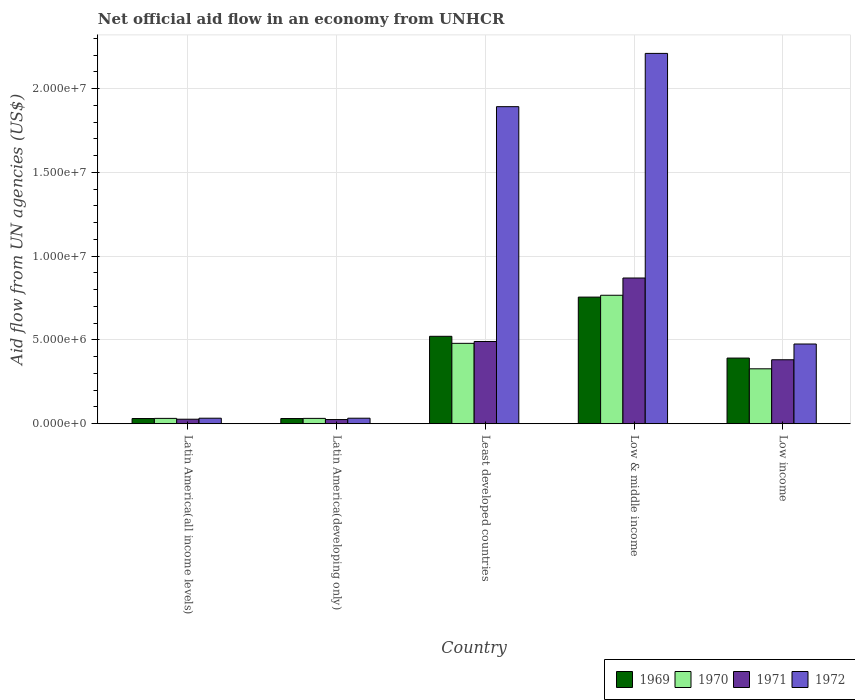How many groups of bars are there?
Ensure brevity in your answer.  5. Are the number of bars on each tick of the X-axis equal?
Your answer should be very brief. Yes. How many bars are there on the 2nd tick from the left?
Offer a very short reply. 4. How many bars are there on the 5th tick from the right?
Provide a short and direct response. 4. What is the label of the 3rd group of bars from the left?
Provide a short and direct response. Least developed countries. What is the net official aid flow in 1969 in Low & middle income?
Your answer should be very brief. 7.56e+06. Across all countries, what is the maximum net official aid flow in 1969?
Provide a short and direct response. 7.56e+06. In which country was the net official aid flow in 1969 minimum?
Give a very brief answer. Latin America(all income levels). What is the total net official aid flow in 1969 in the graph?
Keep it short and to the point. 1.73e+07. What is the difference between the net official aid flow in 1970 in Latin America(all income levels) and that in Low & middle income?
Your answer should be compact. -7.35e+06. What is the average net official aid flow in 1972 per country?
Your response must be concise. 9.29e+06. What is the difference between the net official aid flow of/in 1971 and net official aid flow of/in 1969 in Least developed countries?
Provide a succinct answer. -3.10e+05. In how many countries, is the net official aid flow in 1969 greater than 21000000 US$?
Ensure brevity in your answer.  0. What is the ratio of the net official aid flow in 1969 in Least developed countries to that in Low & middle income?
Your answer should be compact. 0.69. Is the net official aid flow in 1971 in Latin America(developing only) less than that in Low income?
Provide a short and direct response. Yes. Is the difference between the net official aid flow in 1971 in Least developed countries and Low income greater than the difference between the net official aid flow in 1969 in Least developed countries and Low income?
Offer a terse response. No. What is the difference between the highest and the second highest net official aid flow in 1971?
Ensure brevity in your answer.  4.88e+06. What is the difference between the highest and the lowest net official aid flow in 1971?
Give a very brief answer. 8.45e+06. In how many countries, is the net official aid flow in 1972 greater than the average net official aid flow in 1972 taken over all countries?
Make the answer very short. 2. Is it the case that in every country, the sum of the net official aid flow in 1972 and net official aid flow in 1970 is greater than the sum of net official aid flow in 1969 and net official aid flow in 1971?
Offer a very short reply. No. What does the 3rd bar from the left in Low & middle income represents?
Your response must be concise. 1971. What does the 1st bar from the right in Least developed countries represents?
Offer a very short reply. 1972. Is it the case that in every country, the sum of the net official aid flow in 1970 and net official aid flow in 1971 is greater than the net official aid flow in 1972?
Provide a succinct answer. No. How many countries are there in the graph?
Make the answer very short. 5. Does the graph contain any zero values?
Keep it short and to the point. No. Where does the legend appear in the graph?
Offer a very short reply. Bottom right. How many legend labels are there?
Ensure brevity in your answer.  4. How are the legend labels stacked?
Give a very brief answer. Horizontal. What is the title of the graph?
Your answer should be compact. Net official aid flow in an economy from UNHCR. Does "2001" appear as one of the legend labels in the graph?
Give a very brief answer. No. What is the label or title of the Y-axis?
Your response must be concise. Aid flow from UN agencies (US$). What is the Aid flow from UN agencies (US$) in 1971 in Latin America(all income levels)?
Make the answer very short. 2.70e+05. What is the Aid flow from UN agencies (US$) of 1970 in Latin America(developing only)?
Keep it short and to the point. 3.20e+05. What is the Aid flow from UN agencies (US$) in 1971 in Latin America(developing only)?
Your response must be concise. 2.50e+05. What is the Aid flow from UN agencies (US$) of 1969 in Least developed countries?
Give a very brief answer. 5.22e+06. What is the Aid flow from UN agencies (US$) of 1970 in Least developed countries?
Offer a terse response. 4.80e+06. What is the Aid flow from UN agencies (US$) in 1971 in Least developed countries?
Your answer should be very brief. 4.91e+06. What is the Aid flow from UN agencies (US$) of 1972 in Least developed countries?
Give a very brief answer. 1.89e+07. What is the Aid flow from UN agencies (US$) in 1969 in Low & middle income?
Give a very brief answer. 7.56e+06. What is the Aid flow from UN agencies (US$) in 1970 in Low & middle income?
Ensure brevity in your answer.  7.67e+06. What is the Aid flow from UN agencies (US$) of 1971 in Low & middle income?
Your answer should be very brief. 8.70e+06. What is the Aid flow from UN agencies (US$) in 1972 in Low & middle income?
Keep it short and to the point. 2.21e+07. What is the Aid flow from UN agencies (US$) of 1969 in Low income?
Your answer should be compact. 3.92e+06. What is the Aid flow from UN agencies (US$) in 1970 in Low income?
Your answer should be compact. 3.28e+06. What is the Aid flow from UN agencies (US$) of 1971 in Low income?
Offer a very short reply. 3.82e+06. What is the Aid flow from UN agencies (US$) in 1972 in Low income?
Keep it short and to the point. 4.76e+06. Across all countries, what is the maximum Aid flow from UN agencies (US$) of 1969?
Provide a short and direct response. 7.56e+06. Across all countries, what is the maximum Aid flow from UN agencies (US$) of 1970?
Your answer should be very brief. 7.67e+06. Across all countries, what is the maximum Aid flow from UN agencies (US$) of 1971?
Offer a terse response. 8.70e+06. Across all countries, what is the maximum Aid flow from UN agencies (US$) of 1972?
Offer a very short reply. 2.21e+07. Across all countries, what is the minimum Aid flow from UN agencies (US$) of 1969?
Offer a terse response. 3.10e+05. Across all countries, what is the minimum Aid flow from UN agencies (US$) of 1970?
Ensure brevity in your answer.  3.20e+05. Across all countries, what is the minimum Aid flow from UN agencies (US$) in 1972?
Give a very brief answer. 3.30e+05. What is the total Aid flow from UN agencies (US$) in 1969 in the graph?
Give a very brief answer. 1.73e+07. What is the total Aid flow from UN agencies (US$) in 1970 in the graph?
Ensure brevity in your answer.  1.64e+07. What is the total Aid flow from UN agencies (US$) in 1971 in the graph?
Provide a succinct answer. 1.80e+07. What is the total Aid flow from UN agencies (US$) in 1972 in the graph?
Give a very brief answer. 4.65e+07. What is the difference between the Aid flow from UN agencies (US$) in 1969 in Latin America(all income levels) and that in Latin America(developing only)?
Make the answer very short. 0. What is the difference between the Aid flow from UN agencies (US$) in 1970 in Latin America(all income levels) and that in Latin America(developing only)?
Provide a succinct answer. 0. What is the difference between the Aid flow from UN agencies (US$) in 1971 in Latin America(all income levels) and that in Latin America(developing only)?
Your answer should be compact. 2.00e+04. What is the difference between the Aid flow from UN agencies (US$) of 1969 in Latin America(all income levels) and that in Least developed countries?
Your response must be concise. -4.91e+06. What is the difference between the Aid flow from UN agencies (US$) of 1970 in Latin America(all income levels) and that in Least developed countries?
Your response must be concise. -4.48e+06. What is the difference between the Aid flow from UN agencies (US$) in 1971 in Latin America(all income levels) and that in Least developed countries?
Your response must be concise. -4.64e+06. What is the difference between the Aid flow from UN agencies (US$) in 1972 in Latin America(all income levels) and that in Least developed countries?
Ensure brevity in your answer.  -1.86e+07. What is the difference between the Aid flow from UN agencies (US$) in 1969 in Latin America(all income levels) and that in Low & middle income?
Make the answer very short. -7.25e+06. What is the difference between the Aid flow from UN agencies (US$) of 1970 in Latin America(all income levels) and that in Low & middle income?
Make the answer very short. -7.35e+06. What is the difference between the Aid flow from UN agencies (US$) of 1971 in Latin America(all income levels) and that in Low & middle income?
Provide a short and direct response. -8.43e+06. What is the difference between the Aid flow from UN agencies (US$) in 1972 in Latin America(all income levels) and that in Low & middle income?
Your answer should be compact. -2.18e+07. What is the difference between the Aid flow from UN agencies (US$) of 1969 in Latin America(all income levels) and that in Low income?
Provide a short and direct response. -3.61e+06. What is the difference between the Aid flow from UN agencies (US$) in 1970 in Latin America(all income levels) and that in Low income?
Offer a very short reply. -2.96e+06. What is the difference between the Aid flow from UN agencies (US$) in 1971 in Latin America(all income levels) and that in Low income?
Provide a short and direct response. -3.55e+06. What is the difference between the Aid flow from UN agencies (US$) in 1972 in Latin America(all income levels) and that in Low income?
Provide a succinct answer. -4.43e+06. What is the difference between the Aid flow from UN agencies (US$) of 1969 in Latin America(developing only) and that in Least developed countries?
Give a very brief answer. -4.91e+06. What is the difference between the Aid flow from UN agencies (US$) of 1970 in Latin America(developing only) and that in Least developed countries?
Your answer should be very brief. -4.48e+06. What is the difference between the Aid flow from UN agencies (US$) in 1971 in Latin America(developing only) and that in Least developed countries?
Provide a succinct answer. -4.66e+06. What is the difference between the Aid flow from UN agencies (US$) in 1972 in Latin America(developing only) and that in Least developed countries?
Give a very brief answer. -1.86e+07. What is the difference between the Aid flow from UN agencies (US$) in 1969 in Latin America(developing only) and that in Low & middle income?
Provide a short and direct response. -7.25e+06. What is the difference between the Aid flow from UN agencies (US$) in 1970 in Latin America(developing only) and that in Low & middle income?
Ensure brevity in your answer.  -7.35e+06. What is the difference between the Aid flow from UN agencies (US$) in 1971 in Latin America(developing only) and that in Low & middle income?
Keep it short and to the point. -8.45e+06. What is the difference between the Aid flow from UN agencies (US$) in 1972 in Latin America(developing only) and that in Low & middle income?
Give a very brief answer. -2.18e+07. What is the difference between the Aid flow from UN agencies (US$) in 1969 in Latin America(developing only) and that in Low income?
Give a very brief answer. -3.61e+06. What is the difference between the Aid flow from UN agencies (US$) in 1970 in Latin America(developing only) and that in Low income?
Your answer should be very brief. -2.96e+06. What is the difference between the Aid flow from UN agencies (US$) of 1971 in Latin America(developing only) and that in Low income?
Give a very brief answer. -3.57e+06. What is the difference between the Aid flow from UN agencies (US$) in 1972 in Latin America(developing only) and that in Low income?
Give a very brief answer. -4.43e+06. What is the difference between the Aid flow from UN agencies (US$) in 1969 in Least developed countries and that in Low & middle income?
Keep it short and to the point. -2.34e+06. What is the difference between the Aid flow from UN agencies (US$) of 1970 in Least developed countries and that in Low & middle income?
Give a very brief answer. -2.87e+06. What is the difference between the Aid flow from UN agencies (US$) of 1971 in Least developed countries and that in Low & middle income?
Offer a very short reply. -3.79e+06. What is the difference between the Aid flow from UN agencies (US$) in 1972 in Least developed countries and that in Low & middle income?
Ensure brevity in your answer.  -3.18e+06. What is the difference between the Aid flow from UN agencies (US$) in 1969 in Least developed countries and that in Low income?
Offer a terse response. 1.30e+06. What is the difference between the Aid flow from UN agencies (US$) in 1970 in Least developed countries and that in Low income?
Provide a succinct answer. 1.52e+06. What is the difference between the Aid flow from UN agencies (US$) of 1971 in Least developed countries and that in Low income?
Offer a terse response. 1.09e+06. What is the difference between the Aid flow from UN agencies (US$) in 1972 in Least developed countries and that in Low income?
Keep it short and to the point. 1.42e+07. What is the difference between the Aid flow from UN agencies (US$) in 1969 in Low & middle income and that in Low income?
Your answer should be compact. 3.64e+06. What is the difference between the Aid flow from UN agencies (US$) of 1970 in Low & middle income and that in Low income?
Give a very brief answer. 4.39e+06. What is the difference between the Aid flow from UN agencies (US$) of 1971 in Low & middle income and that in Low income?
Keep it short and to the point. 4.88e+06. What is the difference between the Aid flow from UN agencies (US$) in 1972 in Low & middle income and that in Low income?
Keep it short and to the point. 1.74e+07. What is the difference between the Aid flow from UN agencies (US$) of 1969 in Latin America(all income levels) and the Aid flow from UN agencies (US$) of 1970 in Latin America(developing only)?
Your response must be concise. -10000. What is the difference between the Aid flow from UN agencies (US$) in 1969 in Latin America(all income levels) and the Aid flow from UN agencies (US$) in 1970 in Least developed countries?
Keep it short and to the point. -4.49e+06. What is the difference between the Aid flow from UN agencies (US$) in 1969 in Latin America(all income levels) and the Aid flow from UN agencies (US$) in 1971 in Least developed countries?
Provide a short and direct response. -4.60e+06. What is the difference between the Aid flow from UN agencies (US$) of 1969 in Latin America(all income levels) and the Aid flow from UN agencies (US$) of 1972 in Least developed countries?
Offer a very short reply. -1.86e+07. What is the difference between the Aid flow from UN agencies (US$) in 1970 in Latin America(all income levels) and the Aid flow from UN agencies (US$) in 1971 in Least developed countries?
Offer a terse response. -4.59e+06. What is the difference between the Aid flow from UN agencies (US$) of 1970 in Latin America(all income levels) and the Aid flow from UN agencies (US$) of 1972 in Least developed countries?
Give a very brief answer. -1.86e+07. What is the difference between the Aid flow from UN agencies (US$) of 1971 in Latin America(all income levels) and the Aid flow from UN agencies (US$) of 1972 in Least developed countries?
Your answer should be very brief. -1.87e+07. What is the difference between the Aid flow from UN agencies (US$) in 1969 in Latin America(all income levels) and the Aid flow from UN agencies (US$) in 1970 in Low & middle income?
Your answer should be very brief. -7.36e+06. What is the difference between the Aid flow from UN agencies (US$) in 1969 in Latin America(all income levels) and the Aid flow from UN agencies (US$) in 1971 in Low & middle income?
Keep it short and to the point. -8.39e+06. What is the difference between the Aid flow from UN agencies (US$) in 1969 in Latin America(all income levels) and the Aid flow from UN agencies (US$) in 1972 in Low & middle income?
Give a very brief answer. -2.18e+07. What is the difference between the Aid flow from UN agencies (US$) of 1970 in Latin America(all income levels) and the Aid flow from UN agencies (US$) of 1971 in Low & middle income?
Ensure brevity in your answer.  -8.38e+06. What is the difference between the Aid flow from UN agencies (US$) in 1970 in Latin America(all income levels) and the Aid flow from UN agencies (US$) in 1972 in Low & middle income?
Provide a succinct answer. -2.18e+07. What is the difference between the Aid flow from UN agencies (US$) of 1971 in Latin America(all income levels) and the Aid flow from UN agencies (US$) of 1972 in Low & middle income?
Offer a very short reply. -2.18e+07. What is the difference between the Aid flow from UN agencies (US$) in 1969 in Latin America(all income levels) and the Aid flow from UN agencies (US$) in 1970 in Low income?
Your response must be concise. -2.97e+06. What is the difference between the Aid flow from UN agencies (US$) of 1969 in Latin America(all income levels) and the Aid flow from UN agencies (US$) of 1971 in Low income?
Ensure brevity in your answer.  -3.51e+06. What is the difference between the Aid flow from UN agencies (US$) of 1969 in Latin America(all income levels) and the Aid flow from UN agencies (US$) of 1972 in Low income?
Keep it short and to the point. -4.45e+06. What is the difference between the Aid flow from UN agencies (US$) in 1970 in Latin America(all income levels) and the Aid flow from UN agencies (US$) in 1971 in Low income?
Keep it short and to the point. -3.50e+06. What is the difference between the Aid flow from UN agencies (US$) of 1970 in Latin America(all income levels) and the Aid flow from UN agencies (US$) of 1972 in Low income?
Provide a short and direct response. -4.44e+06. What is the difference between the Aid flow from UN agencies (US$) in 1971 in Latin America(all income levels) and the Aid flow from UN agencies (US$) in 1972 in Low income?
Make the answer very short. -4.49e+06. What is the difference between the Aid flow from UN agencies (US$) of 1969 in Latin America(developing only) and the Aid flow from UN agencies (US$) of 1970 in Least developed countries?
Provide a short and direct response. -4.49e+06. What is the difference between the Aid flow from UN agencies (US$) in 1969 in Latin America(developing only) and the Aid flow from UN agencies (US$) in 1971 in Least developed countries?
Make the answer very short. -4.60e+06. What is the difference between the Aid flow from UN agencies (US$) of 1969 in Latin America(developing only) and the Aid flow from UN agencies (US$) of 1972 in Least developed countries?
Your response must be concise. -1.86e+07. What is the difference between the Aid flow from UN agencies (US$) of 1970 in Latin America(developing only) and the Aid flow from UN agencies (US$) of 1971 in Least developed countries?
Offer a very short reply. -4.59e+06. What is the difference between the Aid flow from UN agencies (US$) in 1970 in Latin America(developing only) and the Aid flow from UN agencies (US$) in 1972 in Least developed countries?
Give a very brief answer. -1.86e+07. What is the difference between the Aid flow from UN agencies (US$) in 1971 in Latin America(developing only) and the Aid flow from UN agencies (US$) in 1972 in Least developed countries?
Your answer should be compact. -1.87e+07. What is the difference between the Aid flow from UN agencies (US$) in 1969 in Latin America(developing only) and the Aid flow from UN agencies (US$) in 1970 in Low & middle income?
Provide a short and direct response. -7.36e+06. What is the difference between the Aid flow from UN agencies (US$) in 1969 in Latin America(developing only) and the Aid flow from UN agencies (US$) in 1971 in Low & middle income?
Provide a succinct answer. -8.39e+06. What is the difference between the Aid flow from UN agencies (US$) in 1969 in Latin America(developing only) and the Aid flow from UN agencies (US$) in 1972 in Low & middle income?
Ensure brevity in your answer.  -2.18e+07. What is the difference between the Aid flow from UN agencies (US$) in 1970 in Latin America(developing only) and the Aid flow from UN agencies (US$) in 1971 in Low & middle income?
Make the answer very short. -8.38e+06. What is the difference between the Aid flow from UN agencies (US$) in 1970 in Latin America(developing only) and the Aid flow from UN agencies (US$) in 1972 in Low & middle income?
Your answer should be very brief. -2.18e+07. What is the difference between the Aid flow from UN agencies (US$) in 1971 in Latin America(developing only) and the Aid flow from UN agencies (US$) in 1972 in Low & middle income?
Give a very brief answer. -2.19e+07. What is the difference between the Aid flow from UN agencies (US$) in 1969 in Latin America(developing only) and the Aid flow from UN agencies (US$) in 1970 in Low income?
Keep it short and to the point. -2.97e+06. What is the difference between the Aid flow from UN agencies (US$) of 1969 in Latin America(developing only) and the Aid flow from UN agencies (US$) of 1971 in Low income?
Offer a very short reply. -3.51e+06. What is the difference between the Aid flow from UN agencies (US$) in 1969 in Latin America(developing only) and the Aid flow from UN agencies (US$) in 1972 in Low income?
Give a very brief answer. -4.45e+06. What is the difference between the Aid flow from UN agencies (US$) of 1970 in Latin America(developing only) and the Aid flow from UN agencies (US$) of 1971 in Low income?
Provide a succinct answer. -3.50e+06. What is the difference between the Aid flow from UN agencies (US$) in 1970 in Latin America(developing only) and the Aid flow from UN agencies (US$) in 1972 in Low income?
Your answer should be compact. -4.44e+06. What is the difference between the Aid flow from UN agencies (US$) of 1971 in Latin America(developing only) and the Aid flow from UN agencies (US$) of 1972 in Low income?
Give a very brief answer. -4.51e+06. What is the difference between the Aid flow from UN agencies (US$) of 1969 in Least developed countries and the Aid flow from UN agencies (US$) of 1970 in Low & middle income?
Make the answer very short. -2.45e+06. What is the difference between the Aid flow from UN agencies (US$) of 1969 in Least developed countries and the Aid flow from UN agencies (US$) of 1971 in Low & middle income?
Provide a short and direct response. -3.48e+06. What is the difference between the Aid flow from UN agencies (US$) in 1969 in Least developed countries and the Aid flow from UN agencies (US$) in 1972 in Low & middle income?
Provide a short and direct response. -1.69e+07. What is the difference between the Aid flow from UN agencies (US$) of 1970 in Least developed countries and the Aid flow from UN agencies (US$) of 1971 in Low & middle income?
Provide a short and direct response. -3.90e+06. What is the difference between the Aid flow from UN agencies (US$) in 1970 in Least developed countries and the Aid flow from UN agencies (US$) in 1972 in Low & middle income?
Your response must be concise. -1.73e+07. What is the difference between the Aid flow from UN agencies (US$) of 1971 in Least developed countries and the Aid flow from UN agencies (US$) of 1972 in Low & middle income?
Offer a very short reply. -1.72e+07. What is the difference between the Aid flow from UN agencies (US$) of 1969 in Least developed countries and the Aid flow from UN agencies (US$) of 1970 in Low income?
Your response must be concise. 1.94e+06. What is the difference between the Aid flow from UN agencies (US$) of 1969 in Least developed countries and the Aid flow from UN agencies (US$) of 1971 in Low income?
Make the answer very short. 1.40e+06. What is the difference between the Aid flow from UN agencies (US$) in 1969 in Least developed countries and the Aid flow from UN agencies (US$) in 1972 in Low income?
Provide a short and direct response. 4.60e+05. What is the difference between the Aid flow from UN agencies (US$) in 1970 in Least developed countries and the Aid flow from UN agencies (US$) in 1971 in Low income?
Your answer should be very brief. 9.80e+05. What is the difference between the Aid flow from UN agencies (US$) in 1969 in Low & middle income and the Aid flow from UN agencies (US$) in 1970 in Low income?
Your response must be concise. 4.28e+06. What is the difference between the Aid flow from UN agencies (US$) of 1969 in Low & middle income and the Aid flow from UN agencies (US$) of 1971 in Low income?
Your response must be concise. 3.74e+06. What is the difference between the Aid flow from UN agencies (US$) in 1969 in Low & middle income and the Aid flow from UN agencies (US$) in 1972 in Low income?
Provide a short and direct response. 2.80e+06. What is the difference between the Aid flow from UN agencies (US$) of 1970 in Low & middle income and the Aid flow from UN agencies (US$) of 1971 in Low income?
Provide a succinct answer. 3.85e+06. What is the difference between the Aid flow from UN agencies (US$) in 1970 in Low & middle income and the Aid flow from UN agencies (US$) in 1972 in Low income?
Make the answer very short. 2.91e+06. What is the difference between the Aid flow from UN agencies (US$) in 1971 in Low & middle income and the Aid flow from UN agencies (US$) in 1972 in Low income?
Keep it short and to the point. 3.94e+06. What is the average Aid flow from UN agencies (US$) in 1969 per country?
Keep it short and to the point. 3.46e+06. What is the average Aid flow from UN agencies (US$) in 1970 per country?
Your answer should be compact. 3.28e+06. What is the average Aid flow from UN agencies (US$) of 1971 per country?
Your answer should be very brief. 3.59e+06. What is the average Aid flow from UN agencies (US$) of 1972 per country?
Give a very brief answer. 9.29e+06. What is the difference between the Aid flow from UN agencies (US$) of 1969 and Aid flow from UN agencies (US$) of 1970 in Latin America(all income levels)?
Your answer should be very brief. -10000. What is the difference between the Aid flow from UN agencies (US$) in 1969 and Aid flow from UN agencies (US$) in 1971 in Latin America(all income levels)?
Keep it short and to the point. 4.00e+04. What is the difference between the Aid flow from UN agencies (US$) of 1970 and Aid flow from UN agencies (US$) of 1971 in Latin America(all income levels)?
Offer a terse response. 5.00e+04. What is the difference between the Aid flow from UN agencies (US$) in 1971 and Aid flow from UN agencies (US$) in 1972 in Latin America(all income levels)?
Your answer should be very brief. -6.00e+04. What is the difference between the Aid flow from UN agencies (US$) of 1969 and Aid flow from UN agencies (US$) of 1971 in Latin America(developing only)?
Make the answer very short. 6.00e+04. What is the difference between the Aid flow from UN agencies (US$) of 1970 and Aid flow from UN agencies (US$) of 1971 in Latin America(developing only)?
Offer a very short reply. 7.00e+04. What is the difference between the Aid flow from UN agencies (US$) of 1970 and Aid flow from UN agencies (US$) of 1972 in Latin America(developing only)?
Your response must be concise. -10000. What is the difference between the Aid flow from UN agencies (US$) in 1971 and Aid flow from UN agencies (US$) in 1972 in Latin America(developing only)?
Make the answer very short. -8.00e+04. What is the difference between the Aid flow from UN agencies (US$) in 1969 and Aid flow from UN agencies (US$) in 1972 in Least developed countries?
Offer a terse response. -1.37e+07. What is the difference between the Aid flow from UN agencies (US$) in 1970 and Aid flow from UN agencies (US$) in 1972 in Least developed countries?
Offer a very short reply. -1.41e+07. What is the difference between the Aid flow from UN agencies (US$) in 1971 and Aid flow from UN agencies (US$) in 1972 in Least developed countries?
Provide a succinct answer. -1.40e+07. What is the difference between the Aid flow from UN agencies (US$) in 1969 and Aid flow from UN agencies (US$) in 1970 in Low & middle income?
Offer a terse response. -1.10e+05. What is the difference between the Aid flow from UN agencies (US$) in 1969 and Aid flow from UN agencies (US$) in 1971 in Low & middle income?
Your response must be concise. -1.14e+06. What is the difference between the Aid flow from UN agencies (US$) of 1969 and Aid flow from UN agencies (US$) of 1972 in Low & middle income?
Provide a succinct answer. -1.46e+07. What is the difference between the Aid flow from UN agencies (US$) in 1970 and Aid flow from UN agencies (US$) in 1971 in Low & middle income?
Provide a succinct answer. -1.03e+06. What is the difference between the Aid flow from UN agencies (US$) in 1970 and Aid flow from UN agencies (US$) in 1972 in Low & middle income?
Your answer should be compact. -1.44e+07. What is the difference between the Aid flow from UN agencies (US$) in 1971 and Aid flow from UN agencies (US$) in 1972 in Low & middle income?
Offer a terse response. -1.34e+07. What is the difference between the Aid flow from UN agencies (US$) of 1969 and Aid flow from UN agencies (US$) of 1970 in Low income?
Provide a short and direct response. 6.40e+05. What is the difference between the Aid flow from UN agencies (US$) in 1969 and Aid flow from UN agencies (US$) in 1972 in Low income?
Provide a succinct answer. -8.40e+05. What is the difference between the Aid flow from UN agencies (US$) of 1970 and Aid flow from UN agencies (US$) of 1971 in Low income?
Your answer should be very brief. -5.40e+05. What is the difference between the Aid flow from UN agencies (US$) in 1970 and Aid flow from UN agencies (US$) in 1972 in Low income?
Your answer should be compact. -1.48e+06. What is the difference between the Aid flow from UN agencies (US$) of 1971 and Aid flow from UN agencies (US$) of 1972 in Low income?
Make the answer very short. -9.40e+05. What is the ratio of the Aid flow from UN agencies (US$) in 1969 in Latin America(all income levels) to that in Latin America(developing only)?
Provide a succinct answer. 1. What is the ratio of the Aid flow from UN agencies (US$) of 1971 in Latin America(all income levels) to that in Latin America(developing only)?
Offer a terse response. 1.08. What is the ratio of the Aid flow from UN agencies (US$) in 1972 in Latin America(all income levels) to that in Latin America(developing only)?
Provide a short and direct response. 1. What is the ratio of the Aid flow from UN agencies (US$) in 1969 in Latin America(all income levels) to that in Least developed countries?
Ensure brevity in your answer.  0.06. What is the ratio of the Aid flow from UN agencies (US$) in 1970 in Latin America(all income levels) to that in Least developed countries?
Keep it short and to the point. 0.07. What is the ratio of the Aid flow from UN agencies (US$) in 1971 in Latin America(all income levels) to that in Least developed countries?
Your answer should be compact. 0.06. What is the ratio of the Aid flow from UN agencies (US$) of 1972 in Latin America(all income levels) to that in Least developed countries?
Your answer should be compact. 0.02. What is the ratio of the Aid flow from UN agencies (US$) in 1969 in Latin America(all income levels) to that in Low & middle income?
Keep it short and to the point. 0.04. What is the ratio of the Aid flow from UN agencies (US$) of 1970 in Latin America(all income levels) to that in Low & middle income?
Keep it short and to the point. 0.04. What is the ratio of the Aid flow from UN agencies (US$) of 1971 in Latin America(all income levels) to that in Low & middle income?
Provide a succinct answer. 0.03. What is the ratio of the Aid flow from UN agencies (US$) in 1972 in Latin America(all income levels) to that in Low & middle income?
Your answer should be compact. 0.01. What is the ratio of the Aid flow from UN agencies (US$) of 1969 in Latin America(all income levels) to that in Low income?
Your answer should be very brief. 0.08. What is the ratio of the Aid flow from UN agencies (US$) of 1970 in Latin America(all income levels) to that in Low income?
Provide a succinct answer. 0.1. What is the ratio of the Aid flow from UN agencies (US$) of 1971 in Latin America(all income levels) to that in Low income?
Your response must be concise. 0.07. What is the ratio of the Aid flow from UN agencies (US$) of 1972 in Latin America(all income levels) to that in Low income?
Offer a terse response. 0.07. What is the ratio of the Aid flow from UN agencies (US$) of 1969 in Latin America(developing only) to that in Least developed countries?
Your response must be concise. 0.06. What is the ratio of the Aid flow from UN agencies (US$) in 1970 in Latin America(developing only) to that in Least developed countries?
Your response must be concise. 0.07. What is the ratio of the Aid flow from UN agencies (US$) in 1971 in Latin America(developing only) to that in Least developed countries?
Keep it short and to the point. 0.05. What is the ratio of the Aid flow from UN agencies (US$) in 1972 in Latin America(developing only) to that in Least developed countries?
Keep it short and to the point. 0.02. What is the ratio of the Aid flow from UN agencies (US$) of 1969 in Latin America(developing only) to that in Low & middle income?
Your answer should be compact. 0.04. What is the ratio of the Aid flow from UN agencies (US$) of 1970 in Latin America(developing only) to that in Low & middle income?
Offer a terse response. 0.04. What is the ratio of the Aid flow from UN agencies (US$) of 1971 in Latin America(developing only) to that in Low & middle income?
Make the answer very short. 0.03. What is the ratio of the Aid flow from UN agencies (US$) in 1972 in Latin America(developing only) to that in Low & middle income?
Make the answer very short. 0.01. What is the ratio of the Aid flow from UN agencies (US$) of 1969 in Latin America(developing only) to that in Low income?
Keep it short and to the point. 0.08. What is the ratio of the Aid flow from UN agencies (US$) of 1970 in Latin America(developing only) to that in Low income?
Give a very brief answer. 0.1. What is the ratio of the Aid flow from UN agencies (US$) of 1971 in Latin America(developing only) to that in Low income?
Your answer should be very brief. 0.07. What is the ratio of the Aid flow from UN agencies (US$) of 1972 in Latin America(developing only) to that in Low income?
Your answer should be compact. 0.07. What is the ratio of the Aid flow from UN agencies (US$) in 1969 in Least developed countries to that in Low & middle income?
Provide a short and direct response. 0.69. What is the ratio of the Aid flow from UN agencies (US$) in 1970 in Least developed countries to that in Low & middle income?
Provide a succinct answer. 0.63. What is the ratio of the Aid flow from UN agencies (US$) in 1971 in Least developed countries to that in Low & middle income?
Your answer should be very brief. 0.56. What is the ratio of the Aid flow from UN agencies (US$) of 1972 in Least developed countries to that in Low & middle income?
Offer a terse response. 0.86. What is the ratio of the Aid flow from UN agencies (US$) in 1969 in Least developed countries to that in Low income?
Keep it short and to the point. 1.33. What is the ratio of the Aid flow from UN agencies (US$) of 1970 in Least developed countries to that in Low income?
Ensure brevity in your answer.  1.46. What is the ratio of the Aid flow from UN agencies (US$) of 1971 in Least developed countries to that in Low income?
Make the answer very short. 1.29. What is the ratio of the Aid flow from UN agencies (US$) of 1972 in Least developed countries to that in Low income?
Offer a terse response. 3.98. What is the ratio of the Aid flow from UN agencies (US$) in 1969 in Low & middle income to that in Low income?
Offer a terse response. 1.93. What is the ratio of the Aid flow from UN agencies (US$) of 1970 in Low & middle income to that in Low income?
Provide a short and direct response. 2.34. What is the ratio of the Aid flow from UN agencies (US$) in 1971 in Low & middle income to that in Low income?
Keep it short and to the point. 2.28. What is the ratio of the Aid flow from UN agencies (US$) in 1972 in Low & middle income to that in Low income?
Your answer should be compact. 4.64. What is the difference between the highest and the second highest Aid flow from UN agencies (US$) in 1969?
Provide a succinct answer. 2.34e+06. What is the difference between the highest and the second highest Aid flow from UN agencies (US$) of 1970?
Provide a short and direct response. 2.87e+06. What is the difference between the highest and the second highest Aid flow from UN agencies (US$) of 1971?
Offer a very short reply. 3.79e+06. What is the difference between the highest and the second highest Aid flow from UN agencies (US$) in 1972?
Ensure brevity in your answer.  3.18e+06. What is the difference between the highest and the lowest Aid flow from UN agencies (US$) in 1969?
Your response must be concise. 7.25e+06. What is the difference between the highest and the lowest Aid flow from UN agencies (US$) in 1970?
Your answer should be compact. 7.35e+06. What is the difference between the highest and the lowest Aid flow from UN agencies (US$) in 1971?
Keep it short and to the point. 8.45e+06. What is the difference between the highest and the lowest Aid flow from UN agencies (US$) of 1972?
Ensure brevity in your answer.  2.18e+07. 